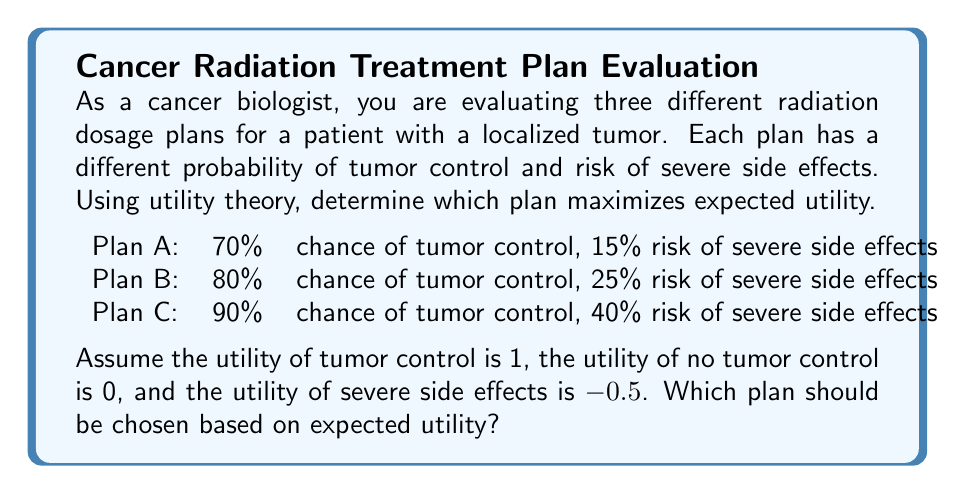Can you answer this question? To solve this problem using utility theory, we need to calculate the expected utility for each plan and choose the one with the highest value. Let's break it down step-by-step:

1. Define the utilities:
   - Utility of tumor control: $U_{TC} = 1$
   - Utility of no tumor control: $U_{NTC} = 0$
   - Utility of severe side effects: $U_{SE} = -0.5$

2. Calculate the expected utility for each plan using the formula:
   $E[U] = P(TC) \cdot U_{TC} + (1 - P(TC)) \cdot U_{NTC} + P(SE) \cdot U_{SE}$

   Where:
   $E[U]$ is the expected utility
   $P(TC)$ is the probability of tumor control
   $P(SE)$ is the probability of severe side effects

3. Calculate expected utility for Plan A:
   $E[U_A] = 0.70 \cdot 1 + (1 - 0.70) \cdot 0 + 0.15 \cdot (-0.5)$
   $E[U_A] = 0.70 + 0 - 0.075 = 0.625$

4. Calculate expected utility for Plan B:
   $E[U_B] = 0.80 \cdot 1 + (1 - 0.80) \cdot 0 + 0.25 \cdot (-0.5)$
   $E[U_B] = 0.80 + 0 - 0.125 = 0.675$

5. Calculate expected utility for Plan C:
   $E[U_C] = 0.90 \cdot 1 + (1 - 0.90) \cdot 0 + 0.40 \cdot (-0.5)$
   $E[U_C] = 0.90 + 0 - 0.20 = 0.70$

6. Compare the expected utilities:
   Plan A: 0.625
   Plan B: 0.675
   Plan C: 0.70

The plan with the highest expected utility is Plan C with a value of 0.70.
Answer: Plan C should be chosen, as it has the highest expected utility of 0.70. 